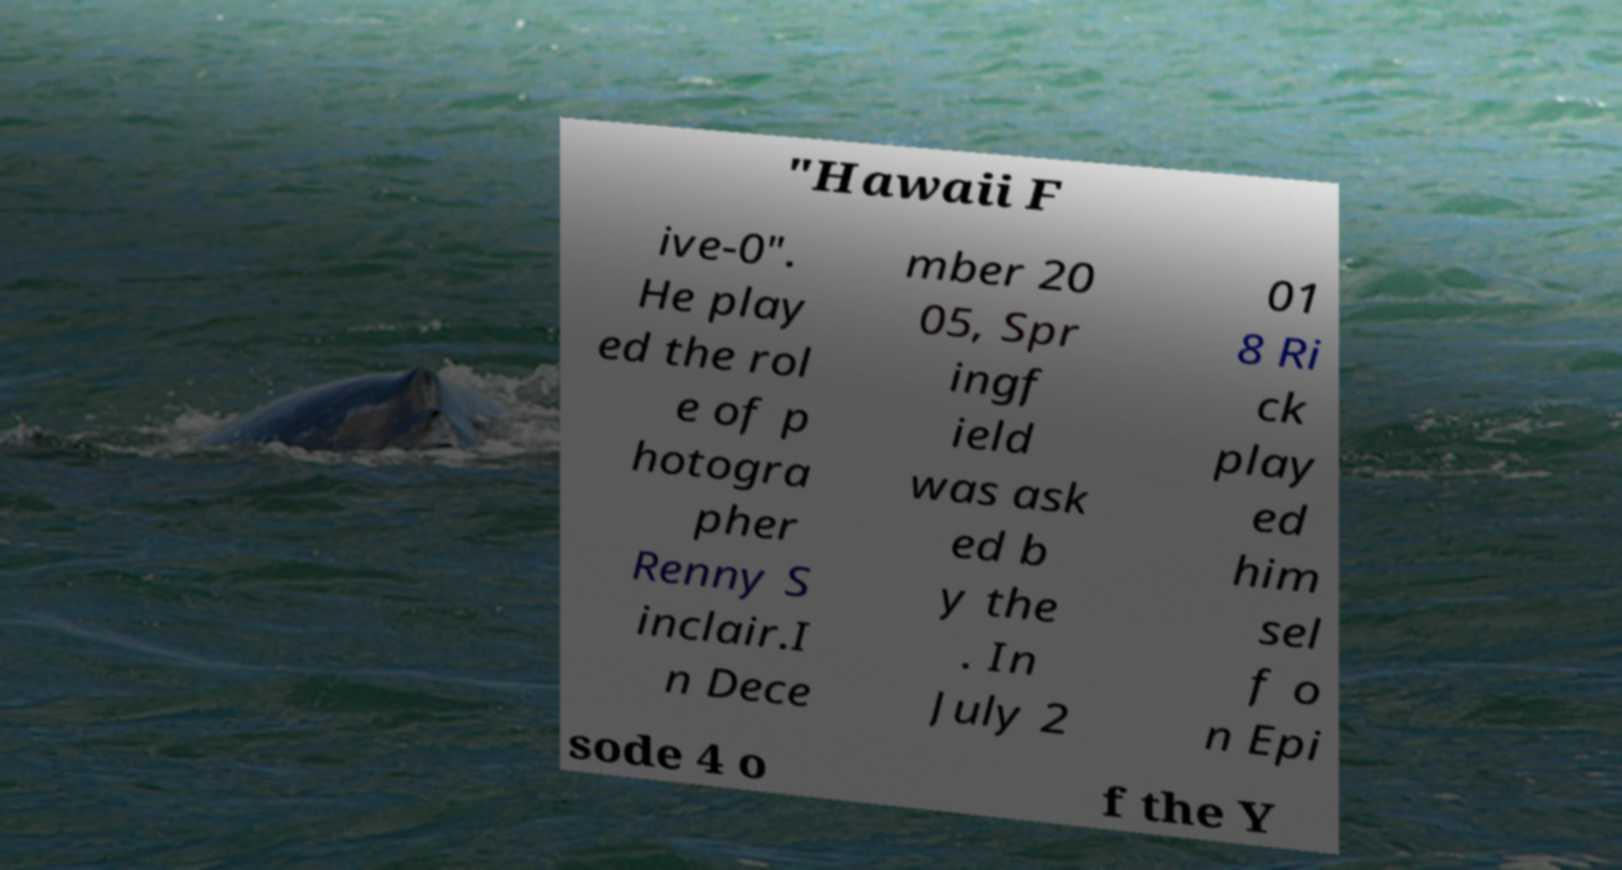There's text embedded in this image that I need extracted. Can you transcribe it verbatim? "Hawaii F ive-0". He play ed the rol e of p hotogra pher Renny S inclair.I n Dece mber 20 05, Spr ingf ield was ask ed b y the . In July 2 01 8 Ri ck play ed him sel f o n Epi sode 4 o f the Y 